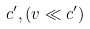<formula> <loc_0><loc_0><loc_500><loc_500>c ^ { \prime } , ( v \ll c ^ { \prime } )</formula> 